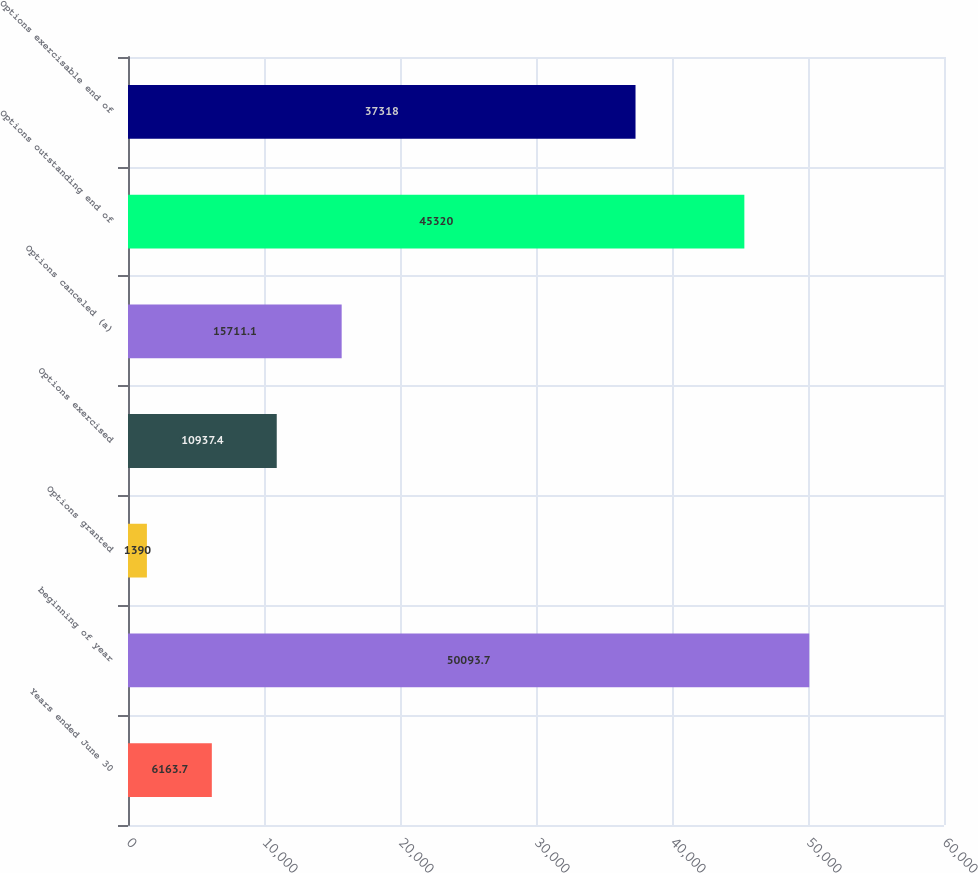Convert chart to OTSL. <chart><loc_0><loc_0><loc_500><loc_500><bar_chart><fcel>Years ended June 30<fcel>beginning of year<fcel>Options granted<fcel>Options exercised<fcel>Options canceled (a)<fcel>Options outstanding end of<fcel>Options exercisable end of<nl><fcel>6163.7<fcel>50093.7<fcel>1390<fcel>10937.4<fcel>15711.1<fcel>45320<fcel>37318<nl></chart> 